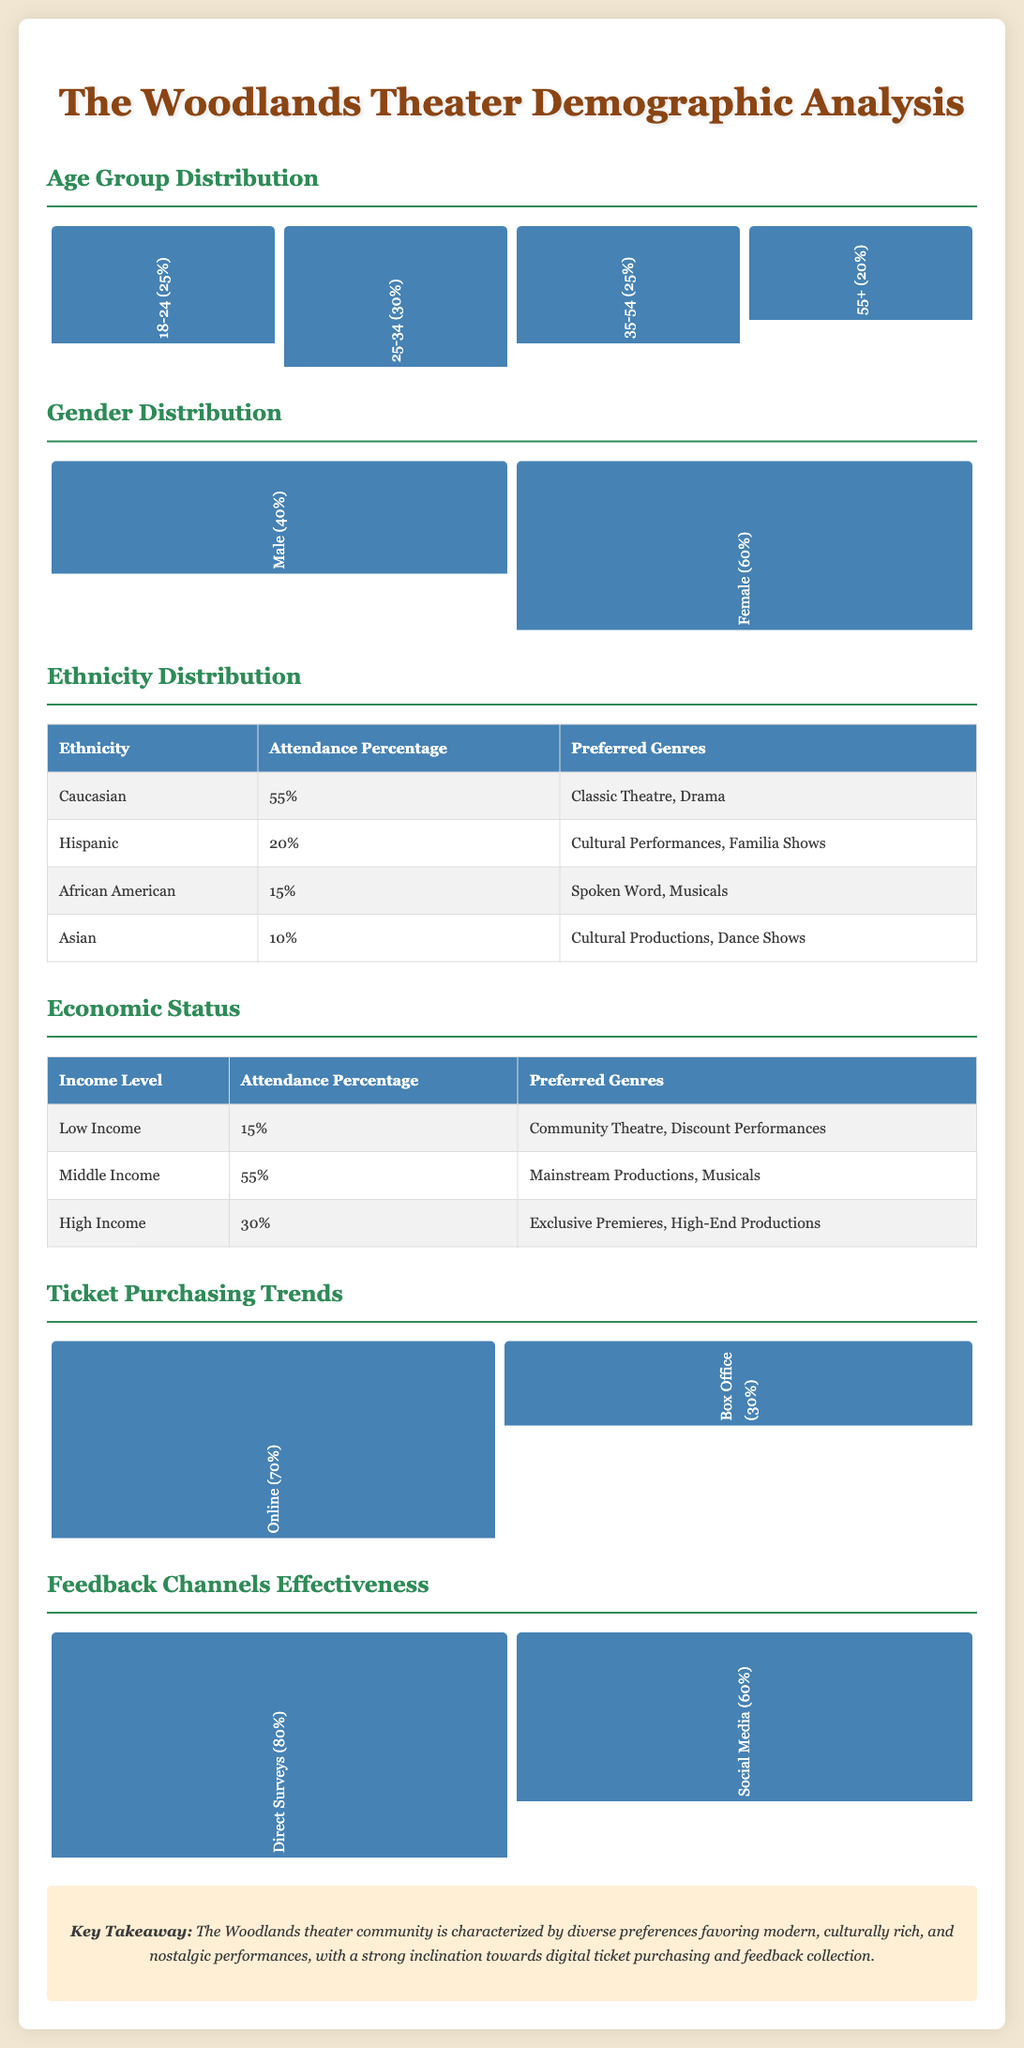what is the percentage of theater attendees aged 25-34? The document states that the percentage of attendees aged 25-34 is 30%.
Answer: 30% what is the gender distribution percentage for females? The document indicates that 60% of theater attendees are female.
Answer: 60% which ethnicity has the highest attendance percentage? According to the document, Caucasian has the highest attendance percentage at 55%.
Answer: Caucasian what percentage of attendees prefer Community Theatre from the low income group? The document specifies that 15% of low-income individuals prefer Community Theatre.
Answer: 15% how are ticket purchases predominantly made? The document reveals that 70% of tickets are purchased online.
Answer: Online what is the preferred genre for Hispanic attendees? The document indicates that Hispanic attendees prefer Cultural Performances and Familia Shows.
Answer: Cultural Performances, Familia Shows which feedback channel was considered the most effective? The document states that Direct Surveys are regarded as the most effective feedback channel at 80%.
Answer: Direct Surveys how many genres do middle-income attendees prefer according to the report? The document lists that middle-income attendees prefer Mainstream Productions and Musicals.
Answer: Mainstream Productions, Musicals what is the age group distribution of attendees aged 55 and above? The document shows that the age group 55+ comprises 20% of attendees.
Answer: 20% 